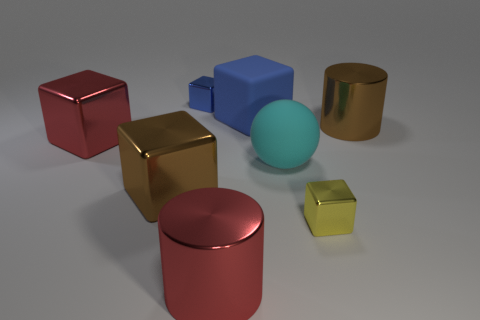What is the color of the other tiny shiny thing that is the same shape as the small yellow metallic object?
Your answer should be compact. Blue. There is a matte block that is the same size as the cyan ball; what is its color?
Offer a terse response. Blue. What size is the cylinder that is to the left of the big cylinder that is behind the block to the right of the matte ball?
Ensure brevity in your answer.  Large. What color is the cube that is both left of the cyan matte sphere and in front of the rubber sphere?
Provide a short and direct response. Brown. What is the size of the red metal object to the left of the red cylinder?
Provide a short and direct response. Large. What number of big green things have the same material as the tiny blue block?
Give a very brief answer. 0. What shape is the small metal thing that is the same color as the matte block?
Provide a succinct answer. Cube. There is a large matte object behind the brown metallic cylinder; does it have the same shape as the small blue thing?
Your answer should be compact. Yes. There is another large block that is made of the same material as the brown block; what color is it?
Offer a terse response. Red. There is a big shiny object to the right of the large red cylinder in front of the big cyan matte ball; are there any objects to the left of it?
Provide a succinct answer. Yes. 